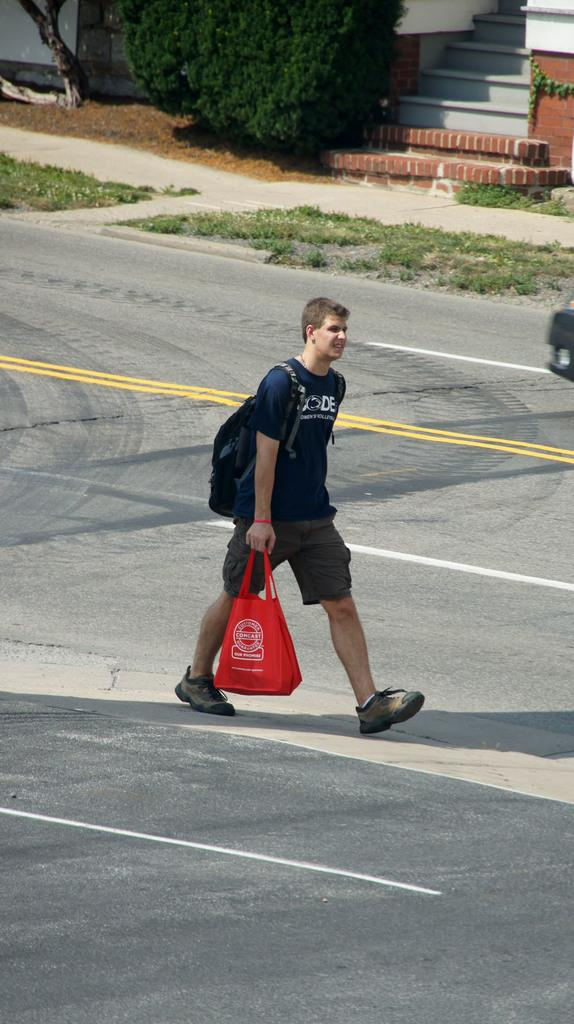What is the man in the image doing? The man is walking on the road. What is the man holding in the image? The man is holding a cover. What type of vegetation can be seen in the image? There is grass in the image. Are there any architectural features present in the image? Yes, there are stairs in the image. What can be seen in the background of the image? Trees are present at the top of the image. What type of stew is being served at the event in the image? There is no event or stew present in the image; it features a man walking on the road while holding a cover. What language is the man speaking in the image? There is no indication of the man speaking in the image, nor is there any information about the language he might be speaking. 